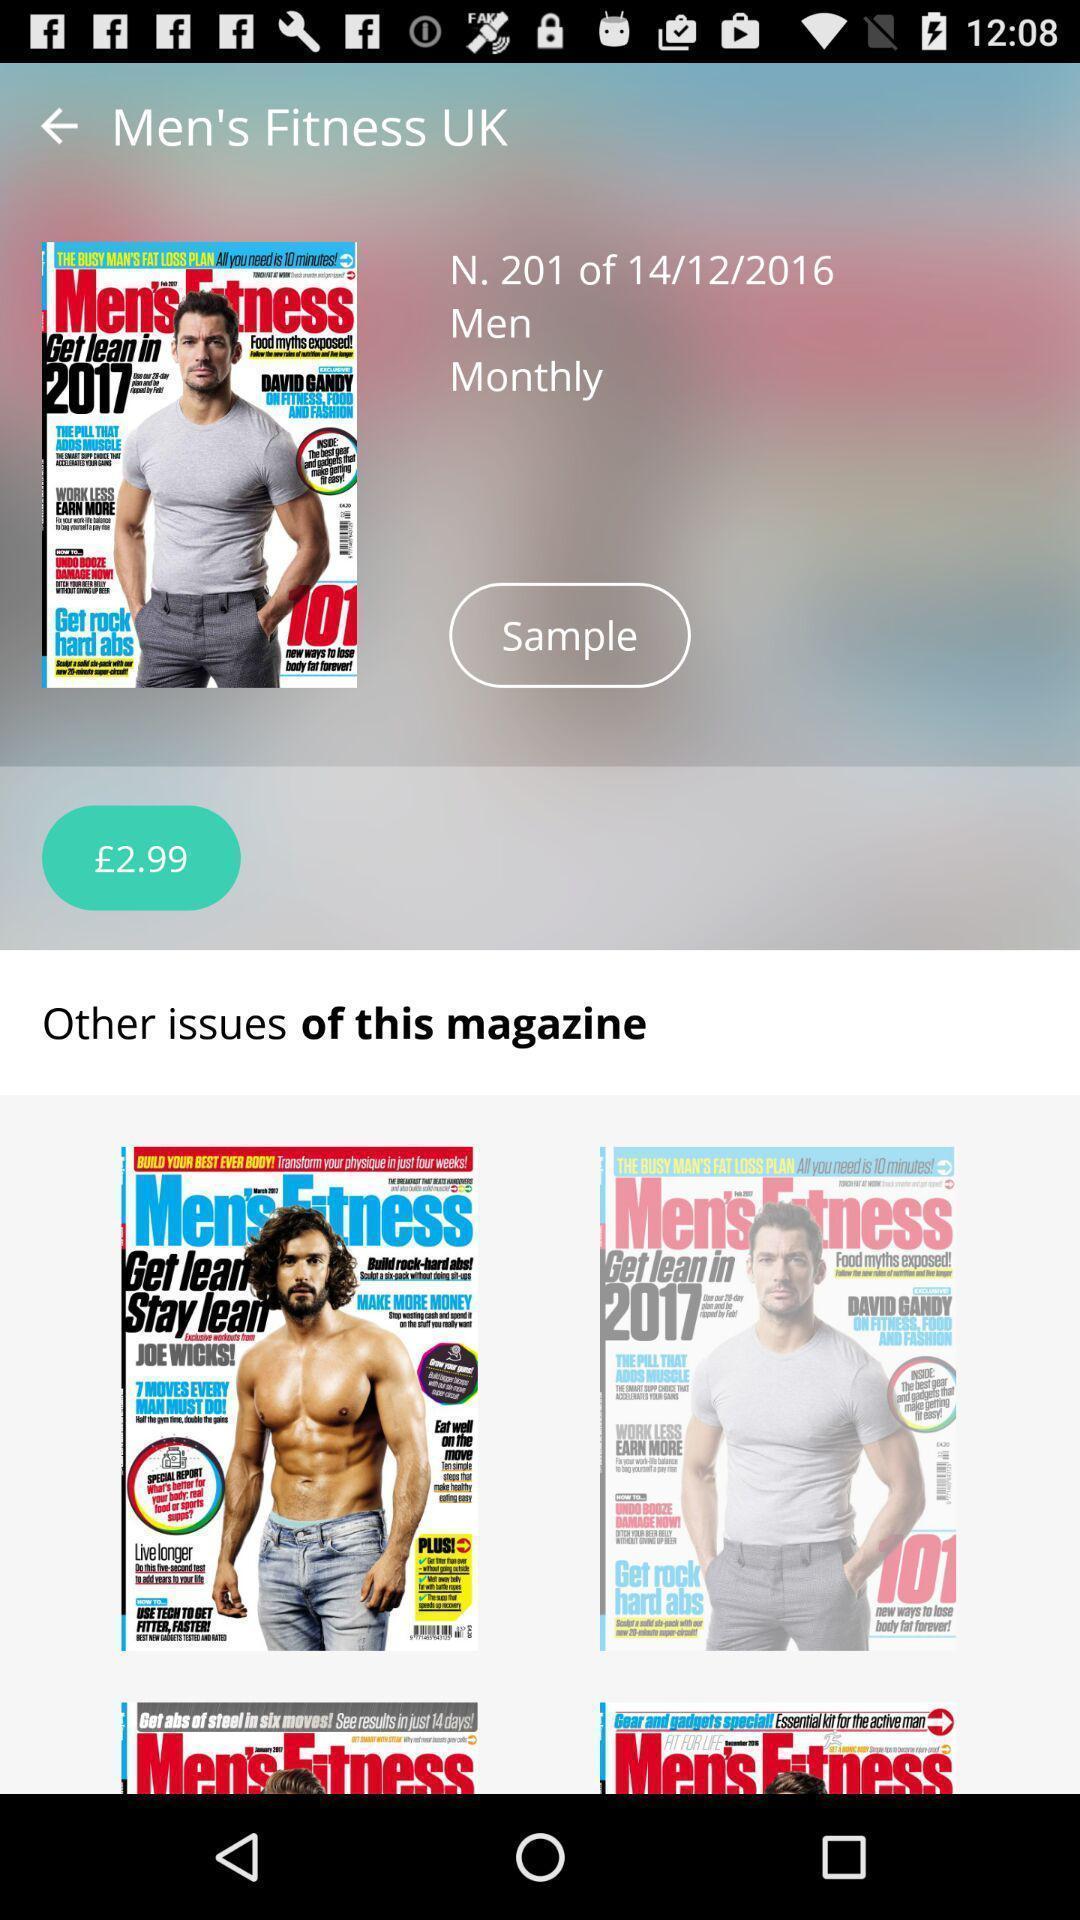Provide a textual representation of this image. Screen displaying fitness magazine for only men. 